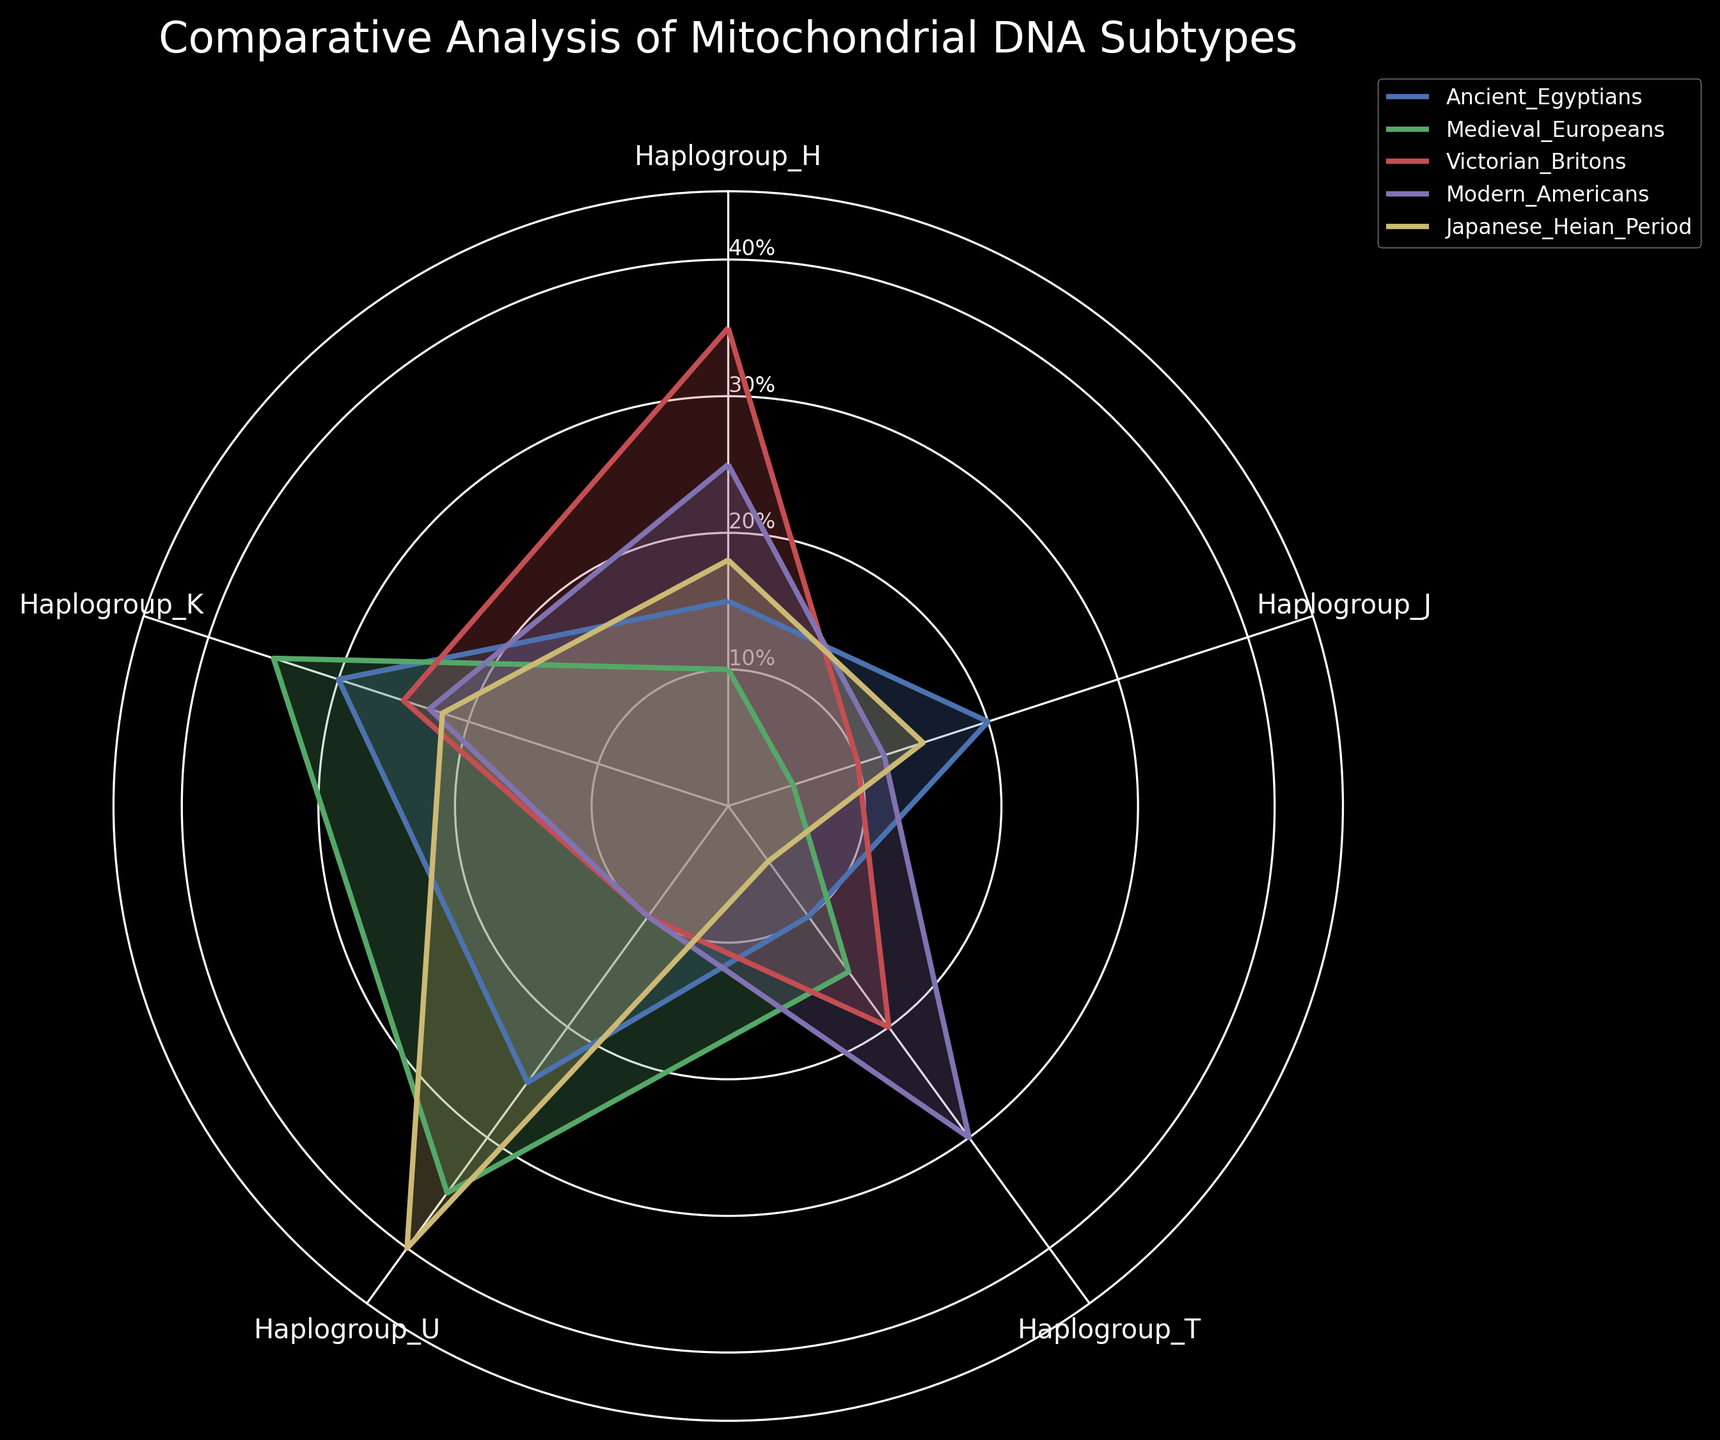What's the title of the radar chart? The title is located at the top of the radar chart and visually stands out due to its font size and placement.
Answer: Comparative Analysis of Mitochondrial DNA Subtypes How many haplogroups are being compared in the chart? The haplogroups are labeled on the chart's axes, forming the vertices of the radar plot. Counting these labels gives us the number of haplogroups.
Answer: 5 Which haplogroup shows the highest value for Japanese Heian Period samples? By looking at the values plotted for Japanese Heian Period and comparing them across all haplogroups, we identify the peak value.
Answer: Haplogroup U What is the percentage of Haplogroup H for Victorian Britons? Locate the Victorian Britons category and find the value on the radar chart for Haplogroup H.
Answer: 35% Compare Haplogroup J values between Modern Americans and Medieval Europeans. Which group has a higher value? Check the length of the plotted lines corresponding to Haplogroup J in both Modern Americans and Medieval Europeans, then compare their lengths.
Answer: Modern Americans What is the average value of Haplogroup K across all sample groups? Sum the values of Haplogroup K for all sample groups and then divide by the number of groups: (30 + 35 + 25 + 23 + 22)/5.
Answer: 27 In which sample group is Haplogroup T the lowest? Identify the lowest plotted point for Haplogroup T by comparing across all groups.
Answer: Japanese Heian Period Rank the sample groups from highest to lowest based on their Haplogroup U values. List Haplogroup U values for all sample groups: Ancient Egyptians (25), Medieval Europeans (35), Victorian Britons (10), Modern Americans (10), and Japanese Heian Period (40), then rank them.
Answer: Japanese Heian Period > Medieval Europeans > Ancient Egyptians > Victorian Britons = Modern Americans Which haplogroup has the most balanced distribution across all sample groups, based on visual assessment? Assess each haplogroup's plotted values to see which one has the least variation across sample groups.
Answer: Haplogroup K What's the total value of Haplogroups H and T for Ancient Egyptians? Sum the values of Haplogroup H and T specifically for Ancient Egyptians: 15 + 10.
Answer: 25 